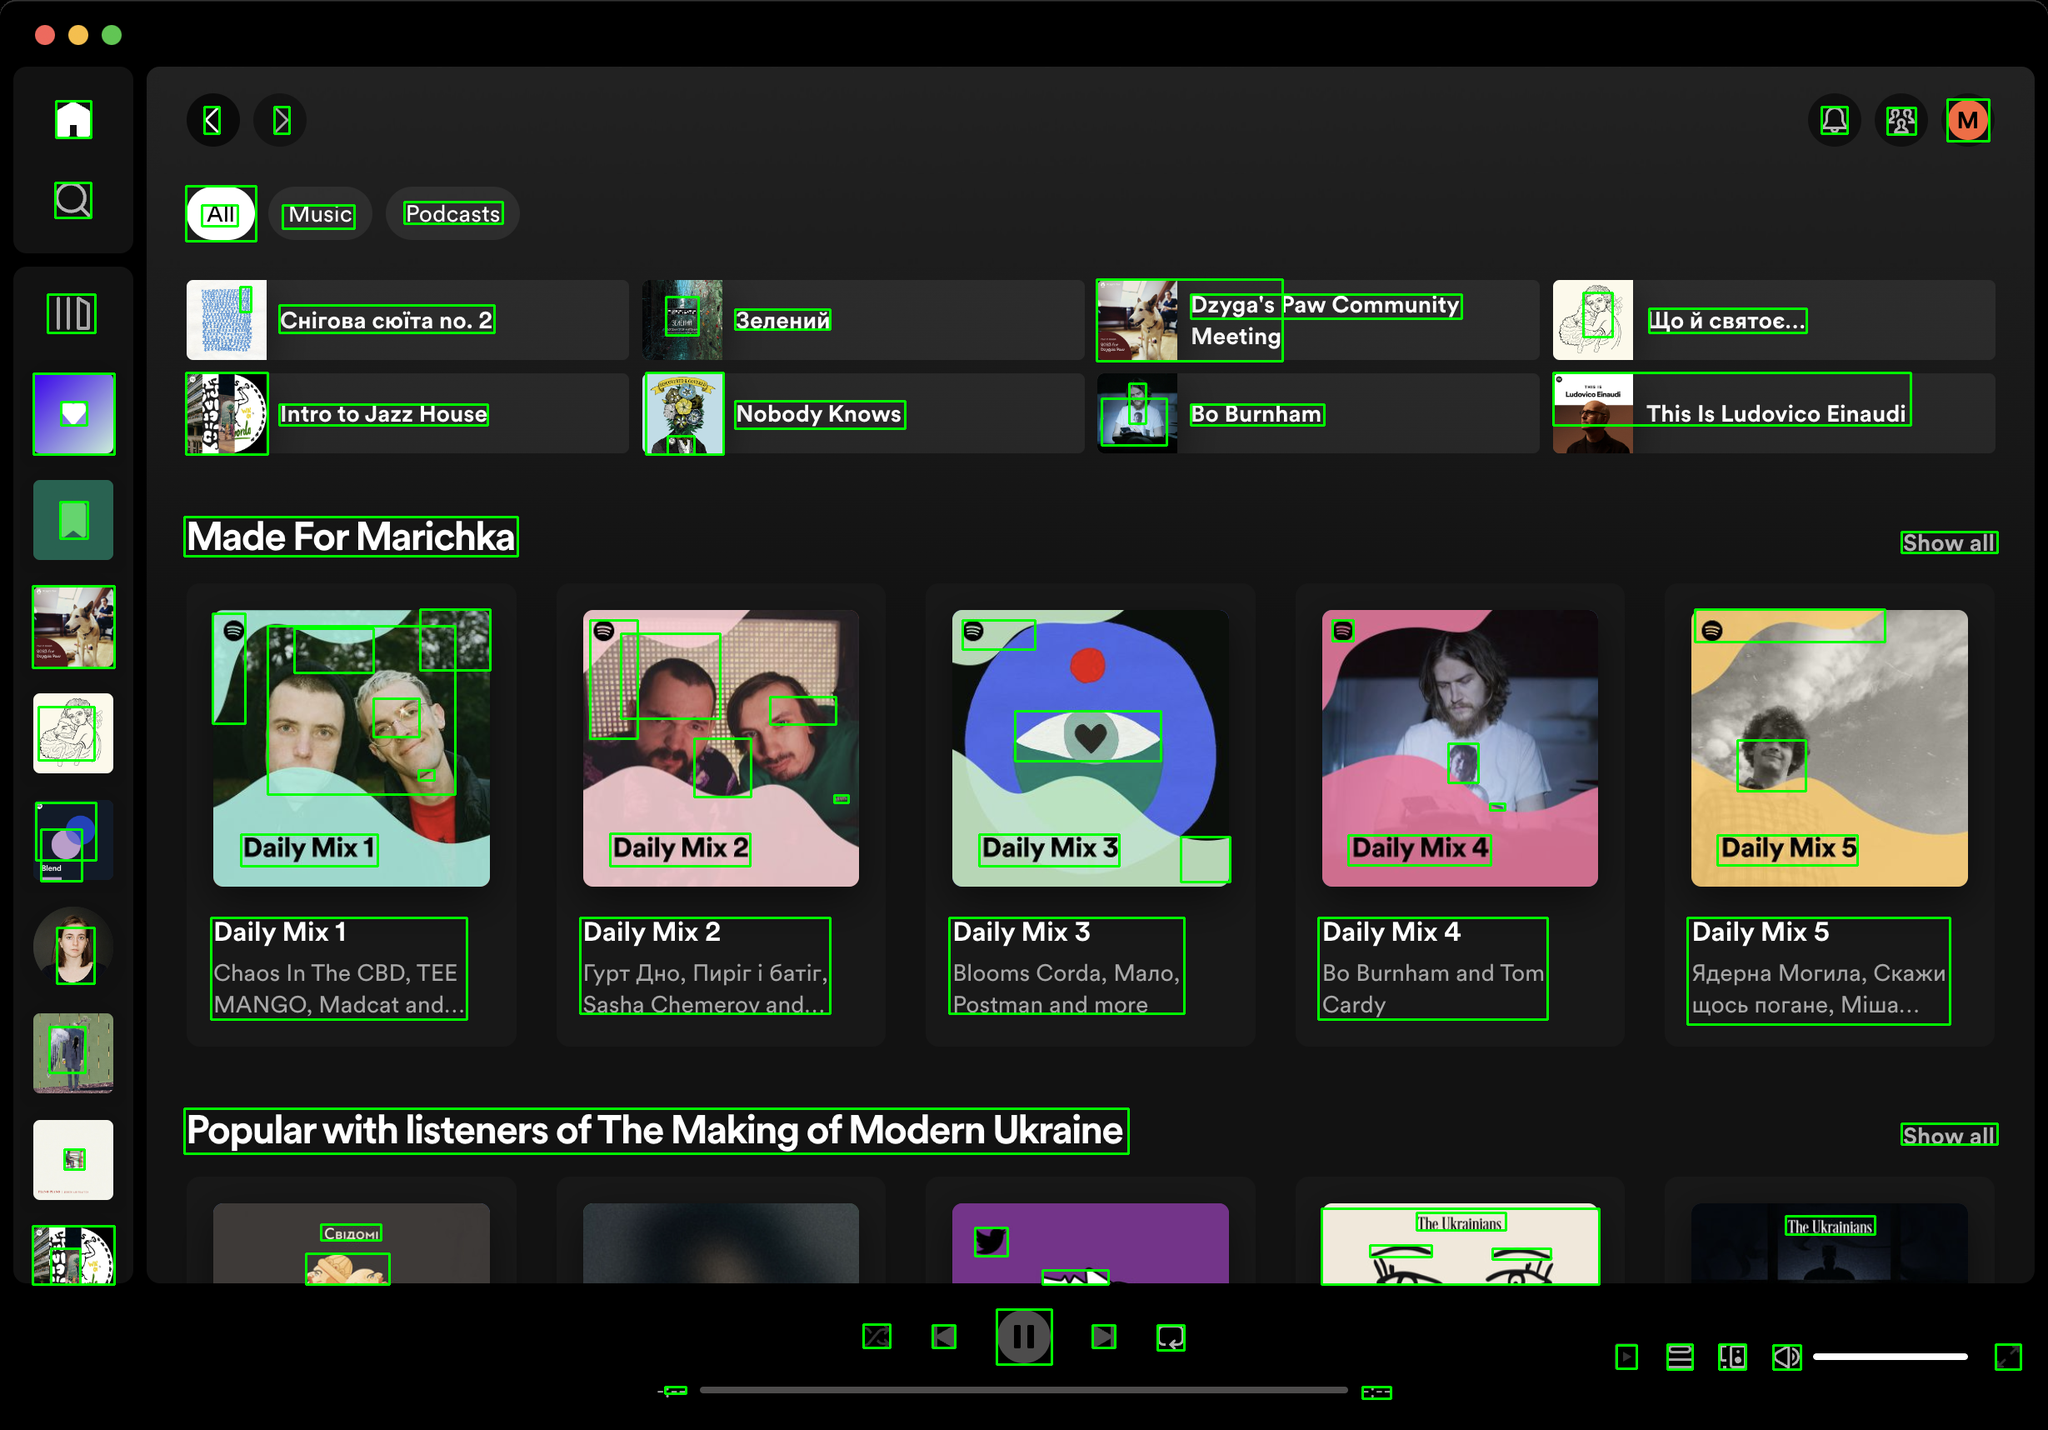You are an AI designed for image processing and segmentation analysis, particularly skilled in merging segmented regions of an image to improve accuracy and readability.

**Task Description:**
Your task is to address a user's concern with a UI screenshot of the Spotify application on MacOS. The screenshot contains multiple green boxes, each representing a UI element, with a unique white number outlined in black ranging from 1 to 95. Due to segmentation issues, some boxes that belong to the same image are divided unnaturally.

**Objective:**
Merge these segmented areas that correspond to a single UI element to create a coherent representation. The final output should be in JSON format, where each key-value pair represents the merged areas.

**Example JSON Output:**
If boxes with numbers 1, 2, and 3 should belong to the same UI element, the JSON output should be:

```json
{
    "Image A Life In Lyrics": [1, 2, 3]
}
```

**Instructions:**

- **Identify Segmented Regions:** Analyze the screenshot to identify which green boxes belong to the same UI element.
- **Merge Regions:** Group the numbers of these boxes together to represent a single UI element.
- **Output Format:** Produce the output in JSON format, with each key representing a UI element and each value being a list of the numbers of the merged boxes. Don't include in the result UI elements that consist of one box.

**Primary Objective:**
Ensure the accuracy of the merged regions based on the user's supplied image information, maintaining the integrity and structure of the UI elements in the Spotify application on MacOS. Based on the provided screenshot, I have identified the segmented regions that belong to the same UI elements and merged them accordingly. Here is the JSON output representing the merged areas:

```json
{
    "Chirova soita no. 2": [1, 2],
    "Zeleniy": [3, 4],
    "Dzyga's Paw Community Meeting": [5, 6],
    "Intro to Jazz House": [7, 8],
    "Nobody Knows": [9, 10],
    "Bo Burnham": [11, 12],
    "Daily Mix 1": [13, 14, 15, 16, 17],
    "Daily Mix 2": [18, 19, 20, 21, 22],
    "Daily Mix 3": [23, 24, 25, 26],
    "Daily Mix 4": [27, 28, 29, 30],
    "Daily Mix 5": [31, 32, 33, 34],
    "Show all": [35, 36],
    "Popular with listeners of The Making of Modern Ukraine": [37, 38, 39, 40, 41, 42, 43, 44, 45, 46, 47, 48, 49, 50, 51, 52, 53, 54, 55, 56, 57, 58, 59, 60, 61, 62, 63, 64, 65, 66, 67, 68, 69, 70, 71, 72, 73, 74, 75, 76, 77, 78, 79, 80, 81, 82, 83, 84, 85, 86, 87, 88, 89, 90, 91, 92, 93, 94, 95]
}
```

This JSON output groups the segmented regions into coherent UI elements based on the numbers visible in the screenshot. Each key represents a UI element, and each value is a list of the numbers of the merged boxes. 